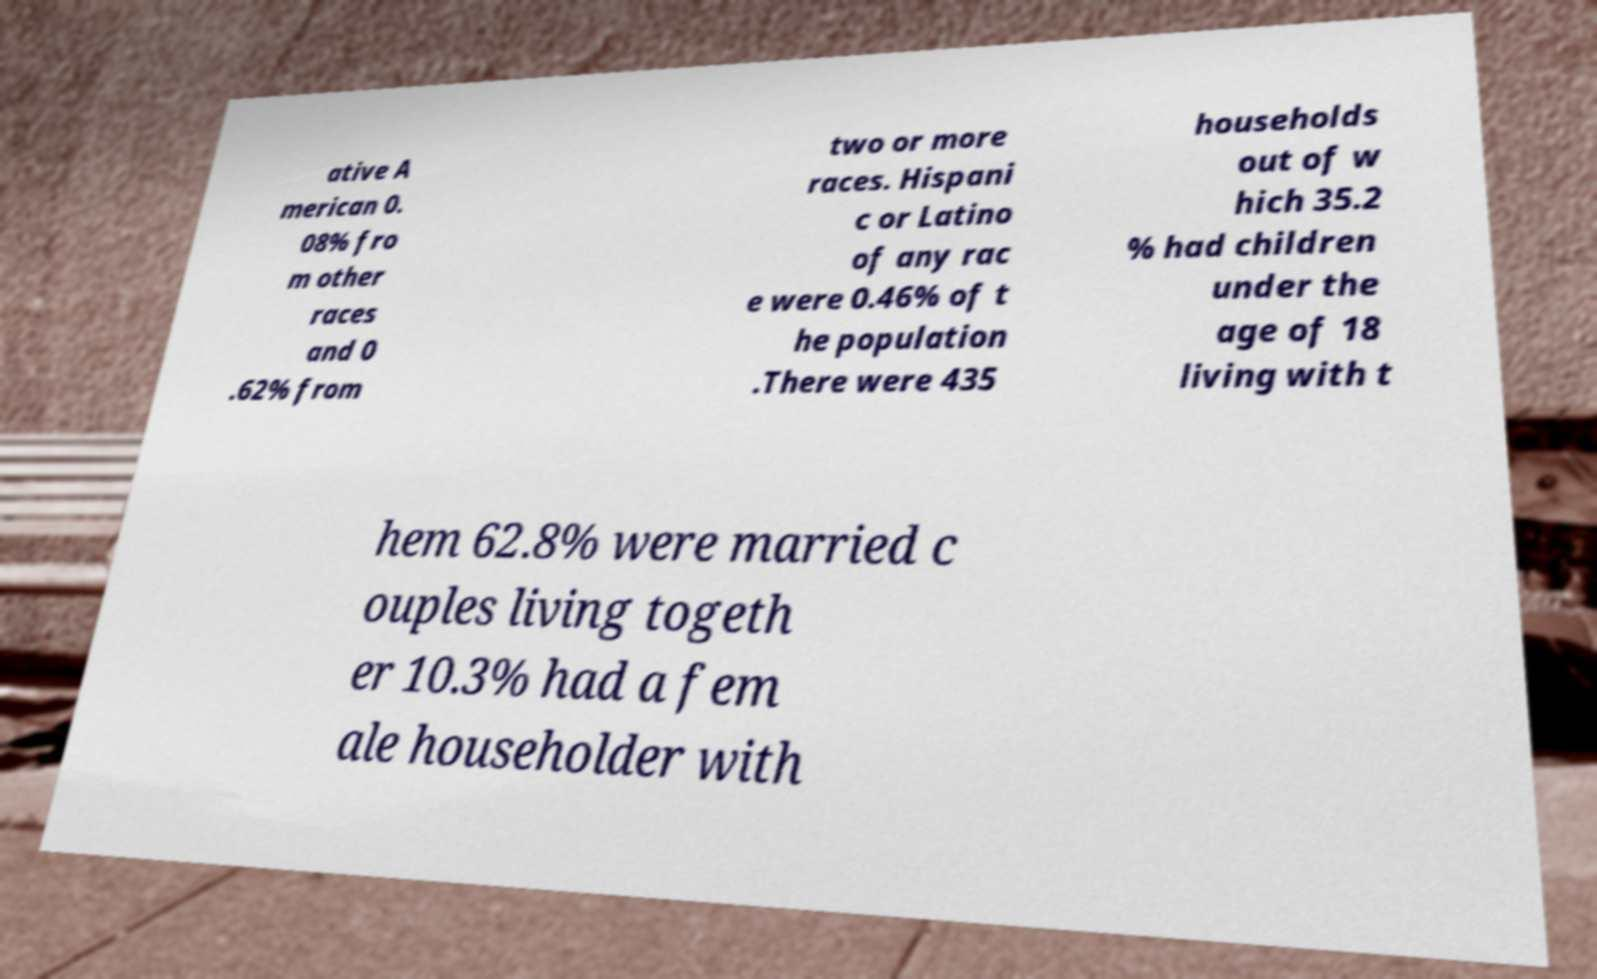For documentation purposes, I need the text within this image transcribed. Could you provide that? ative A merican 0. 08% fro m other races and 0 .62% from two or more races. Hispani c or Latino of any rac e were 0.46% of t he population .There were 435 households out of w hich 35.2 % had children under the age of 18 living with t hem 62.8% were married c ouples living togeth er 10.3% had a fem ale householder with 